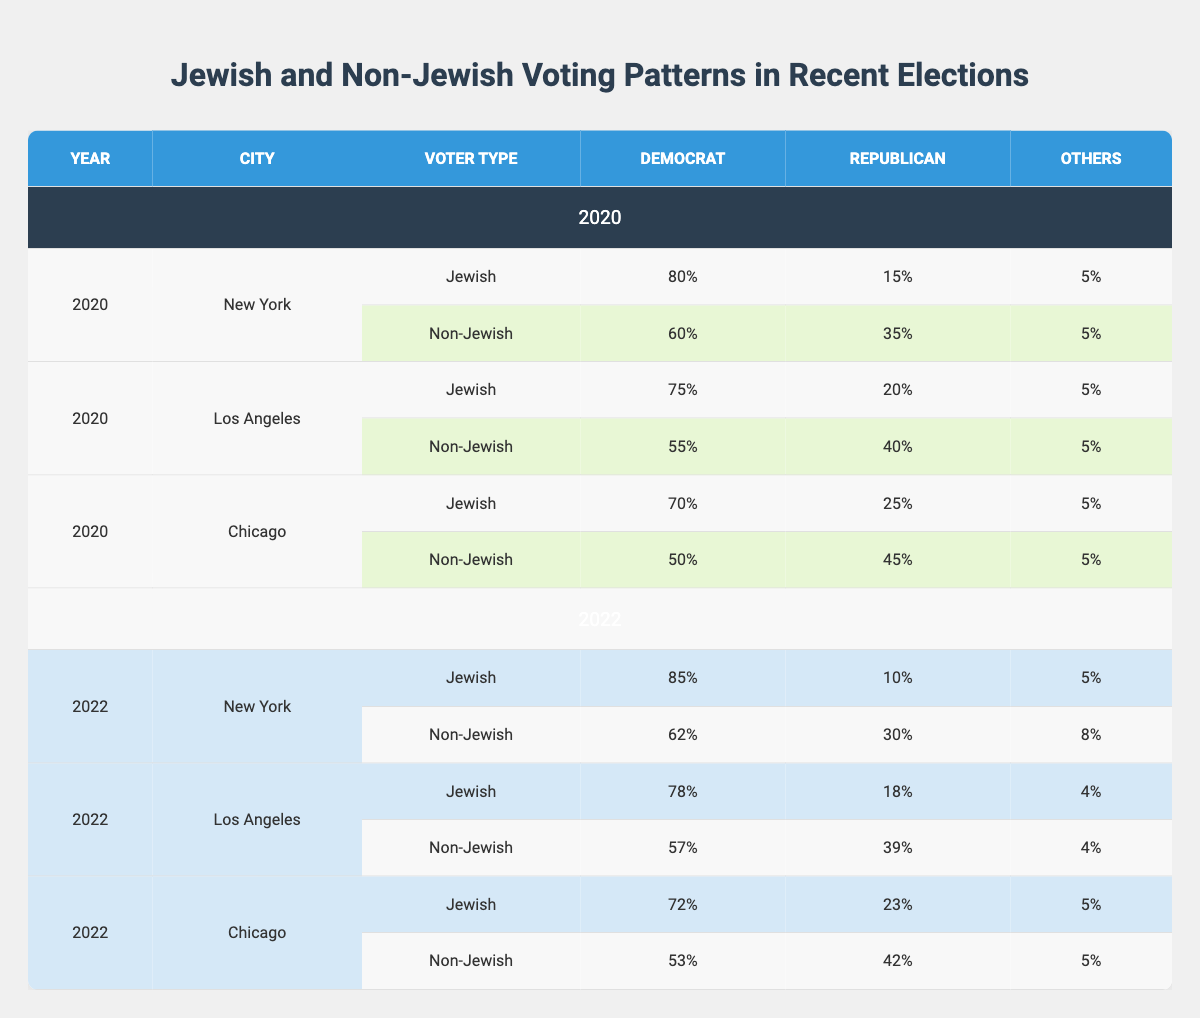What percentage of Jewish voters in New York voted for Democrats in 2020? According to the table, Jewish voters in New York voted 80% for Democrats in 2020. This is directly stated in the table under the 'Jewish' row for New York, 2020.
Answer: 80% What was the total percentage of Republican voters among non-Jewish voters in Chicago for both years? In 2020, non-Jewish Republican voters in Chicago were 45%, and in 2022 it was 42%. Adding these two percentages gives us 45 + 42 = 87.
Answer: 87% Did the percentage of Jewish voters supporting Democrats in Los Angeles increase from 2020 to 2022? Jewish voters in Los Angeles supported Democrats at 75% in 2020 and 78% in 2022. Since 78% is greater than 75%, the percentage did increase.
Answer: Yes What is the average percentage of 'Others' among Jewish voters across all cities in 2020? The percentage of 'Others' among Jewish voters in 2020 for each city is: New York (5%), Los Angeles (5%), and Chicago (5%). The average is calculated as (5 + 5 + 5) / 3 = 5.
Answer: 5 Which city had a higher percentage of Democratic voters among Jewish voters in 2022: New York or Chicago? In 2022, Jewish voters in New York supported Democrats at 85%, while in Chicago they supported Democrats at 72%. Since 85% is greater than 72%, New York had a higher percentage.
Answer: New York What was the difference in the percentage of Democratic voters between Jewish and non-Jewish voters in Los Angeles for 2020? Jewish voters in Los Angeles voted 75% Democrat while non-Jewish voters voted 55%. To find the difference, we subtract: 75 - 55 = 20.
Answer: 20 How did the percentage of Republican voters among non-Jewish voters in New York change from 2020 to 2022? In 2020, non-Jewish Republican voters in New York were 35%, and in 2022 it dropped to 30%. The change can be calculated by subtracting: 35 - 30 = 5.
Answer: Decrease of 5% What percentage of non-Jewish voters chose 'Others' in Chicago in 2022? In the table, non-Jewish voters chose 'Others' in Chicago in 2022 at 5%. This value is directly reported in the non-Jewish row for Chicago in 2022.
Answer: 5% 